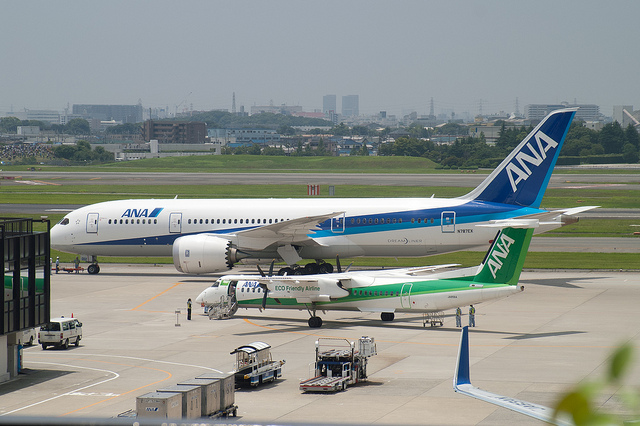Read and extract the text from this image. ANA ANA ANA AVA 